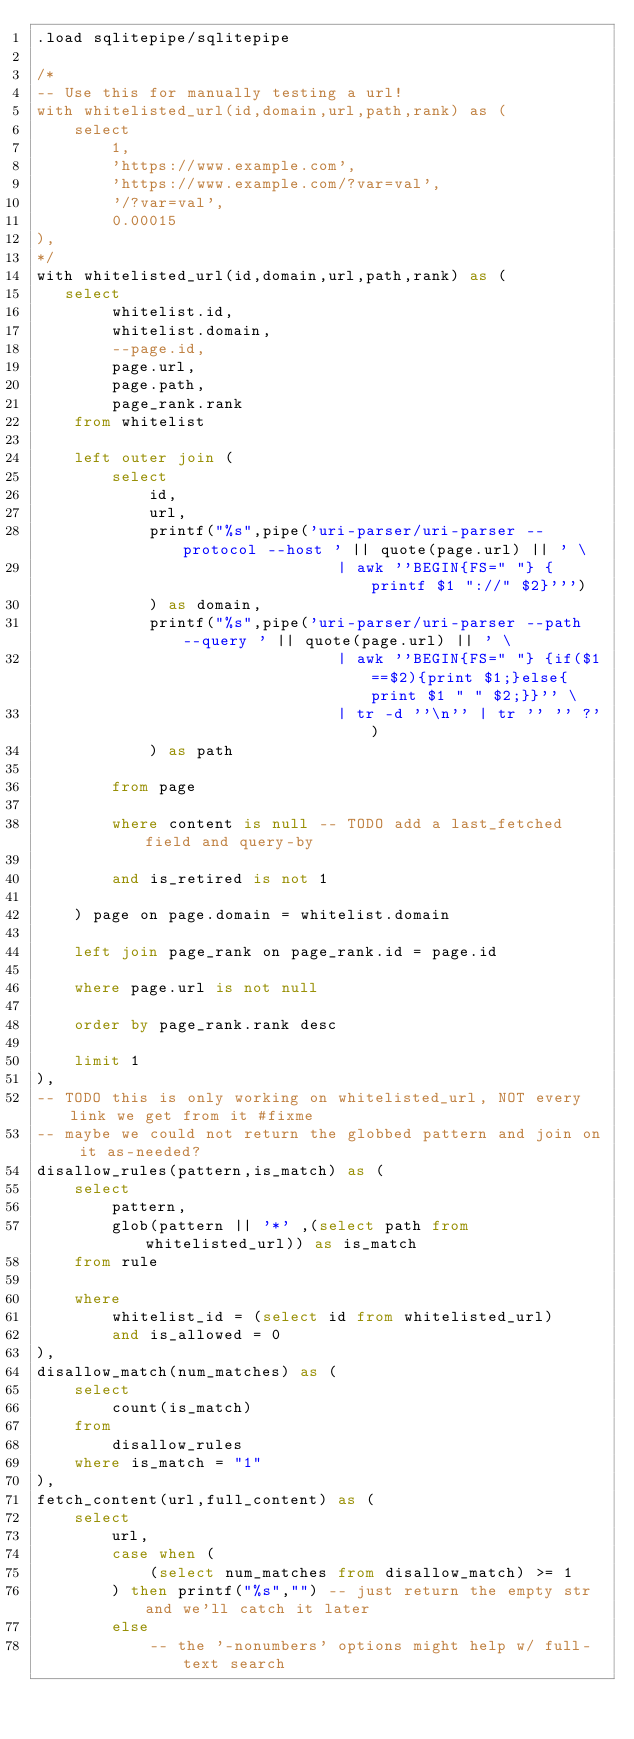<code> <loc_0><loc_0><loc_500><loc_500><_SQL_>.load sqlitepipe/sqlitepipe

/*
-- Use this for manually testing a url!
with whitelisted_url(id,domain,url,path,rank) as (
    select
        1,
        'https://www.example.com',
        'https://www.example.com/?var=val',
        '/?var=val',
        0.00015
),
*/
with whitelisted_url(id,domain,url,path,rank) as (
   select
        whitelist.id,
        whitelist.domain,
        --page.id,
        page.url,
        page.path,
        page_rank.rank
    from whitelist

    left outer join (
        select
            id,
            url,
            printf("%s",pipe('uri-parser/uri-parser --protocol --host ' || quote(page.url) || ' \
                                | awk ''BEGIN{FS=" "} {printf $1 "://" $2}''')
            ) as domain,
            printf("%s",pipe('uri-parser/uri-parser --path --query ' || quote(page.url) || ' \
                                | awk ''BEGIN{FS=" "} {if($1==$2){print $1;}else{print $1 " " $2;}}'' \
                                | tr -d ''\n'' | tr '' '' ?')
            ) as path

        from page

        where content is null -- TODO add a last_fetched field and query-by

        and is_retired is not 1

    ) page on page.domain = whitelist.domain

    left join page_rank on page_rank.id = page.id

    where page.url is not null

    order by page_rank.rank desc

    limit 1
),
-- TODO this is only working on whitelisted_url, NOT every link we get from it #fixme
-- maybe we could not return the globbed pattern and join on it as-needed?
disallow_rules(pattern,is_match) as (
    select
        pattern,
        glob(pattern || '*' ,(select path from whitelisted_url)) as is_match
    from rule

    where
        whitelist_id = (select id from whitelisted_url)
        and is_allowed = 0
),
disallow_match(num_matches) as (
    select
        count(is_match)
    from
        disallow_rules
    where is_match = "1"
),
fetch_content(url,full_content) as (
    select
        url,
        case when (
            (select num_matches from disallow_match) >= 1
        ) then printf("%s","") -- just return the empty str and we'll catch it later
        else
            -- the '-nonumbers' options might help w/ full-text search</code> 